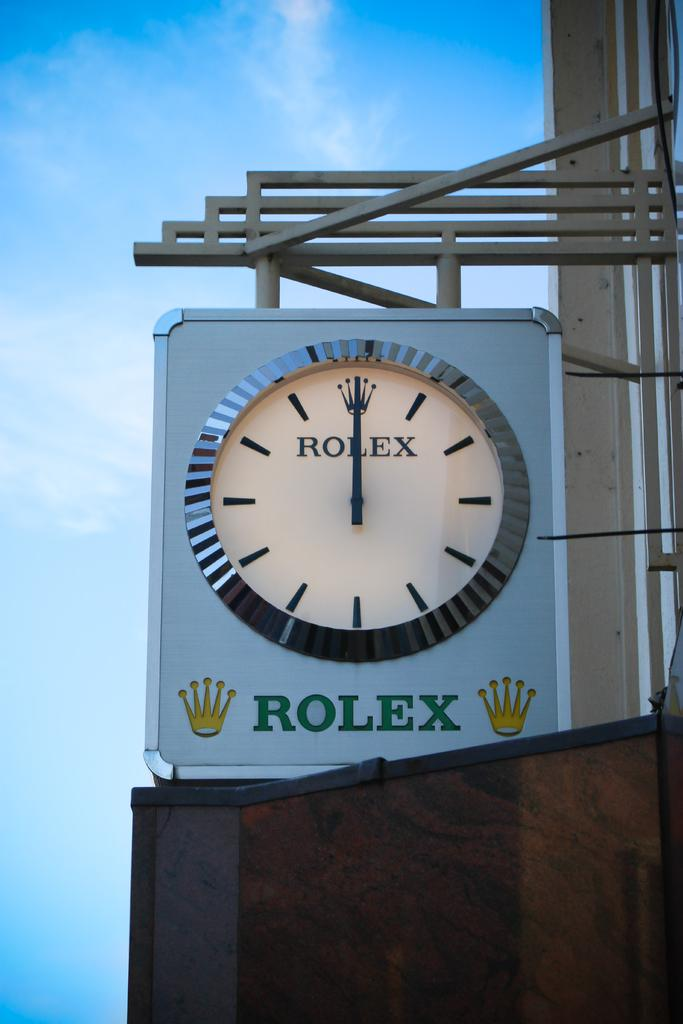<image>
Relay a brief, clear account of the picture shown. A Rolex clock shows the time as 12:00. 